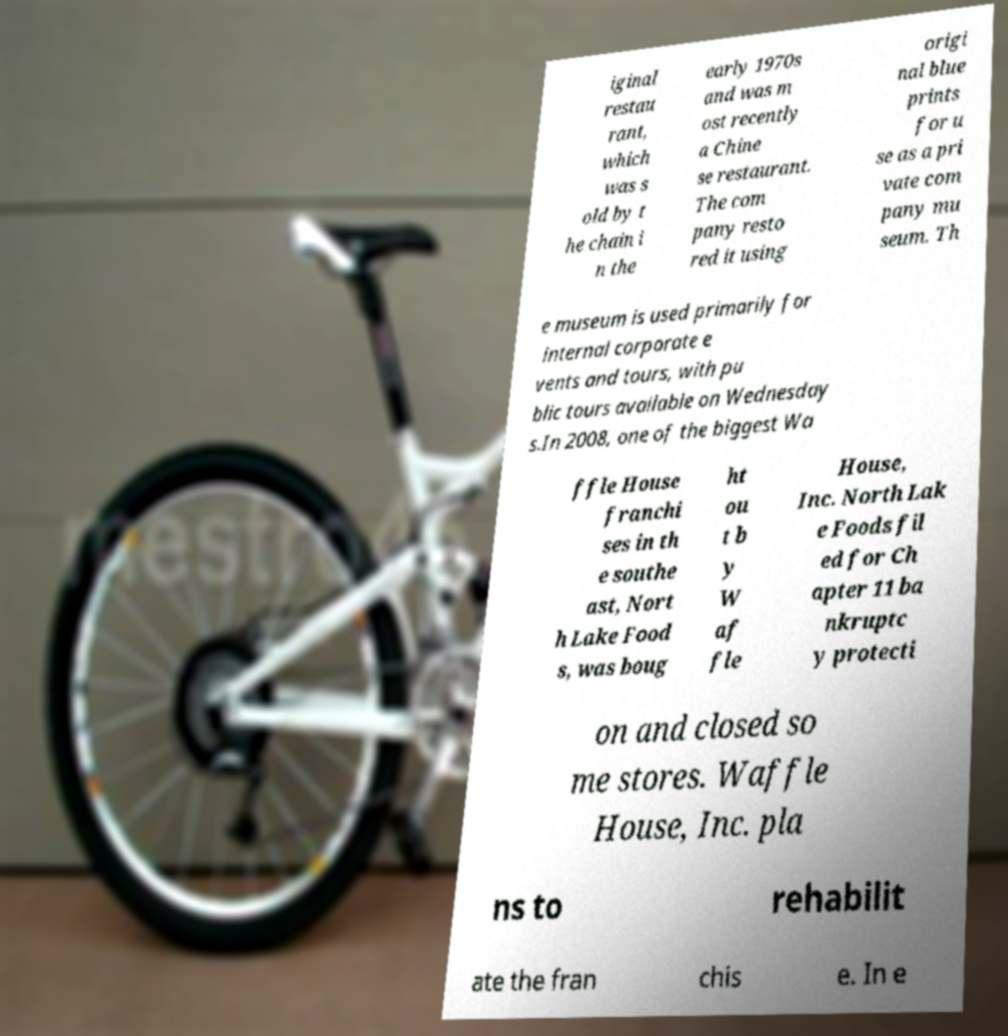Please read and relay the text visible in this image. What does it say? iginal restau rant, which was s old by t he chain i n the early 1970s and was m ost recently a Chine se restaurant. The com pany resto red it using origi nal blue prints for u se as a pri vate com pany mu seum. Th e museum is used primarily for internal corporate e vents and tours, with pu blic tours available on Wednesday s.In 2008, one of the biggest Wa ffle House franchi ses in th e southe ast, Nort h Lake Food s, was boug ht ou t b y W af fle House, Inc. North Lak e Foods fil ed for Ch apter 11 ba nkruptc y protecti on and closed so me stores. Waffle House, Inc. pla ns to rehabilit ate the fran chis e. In e 